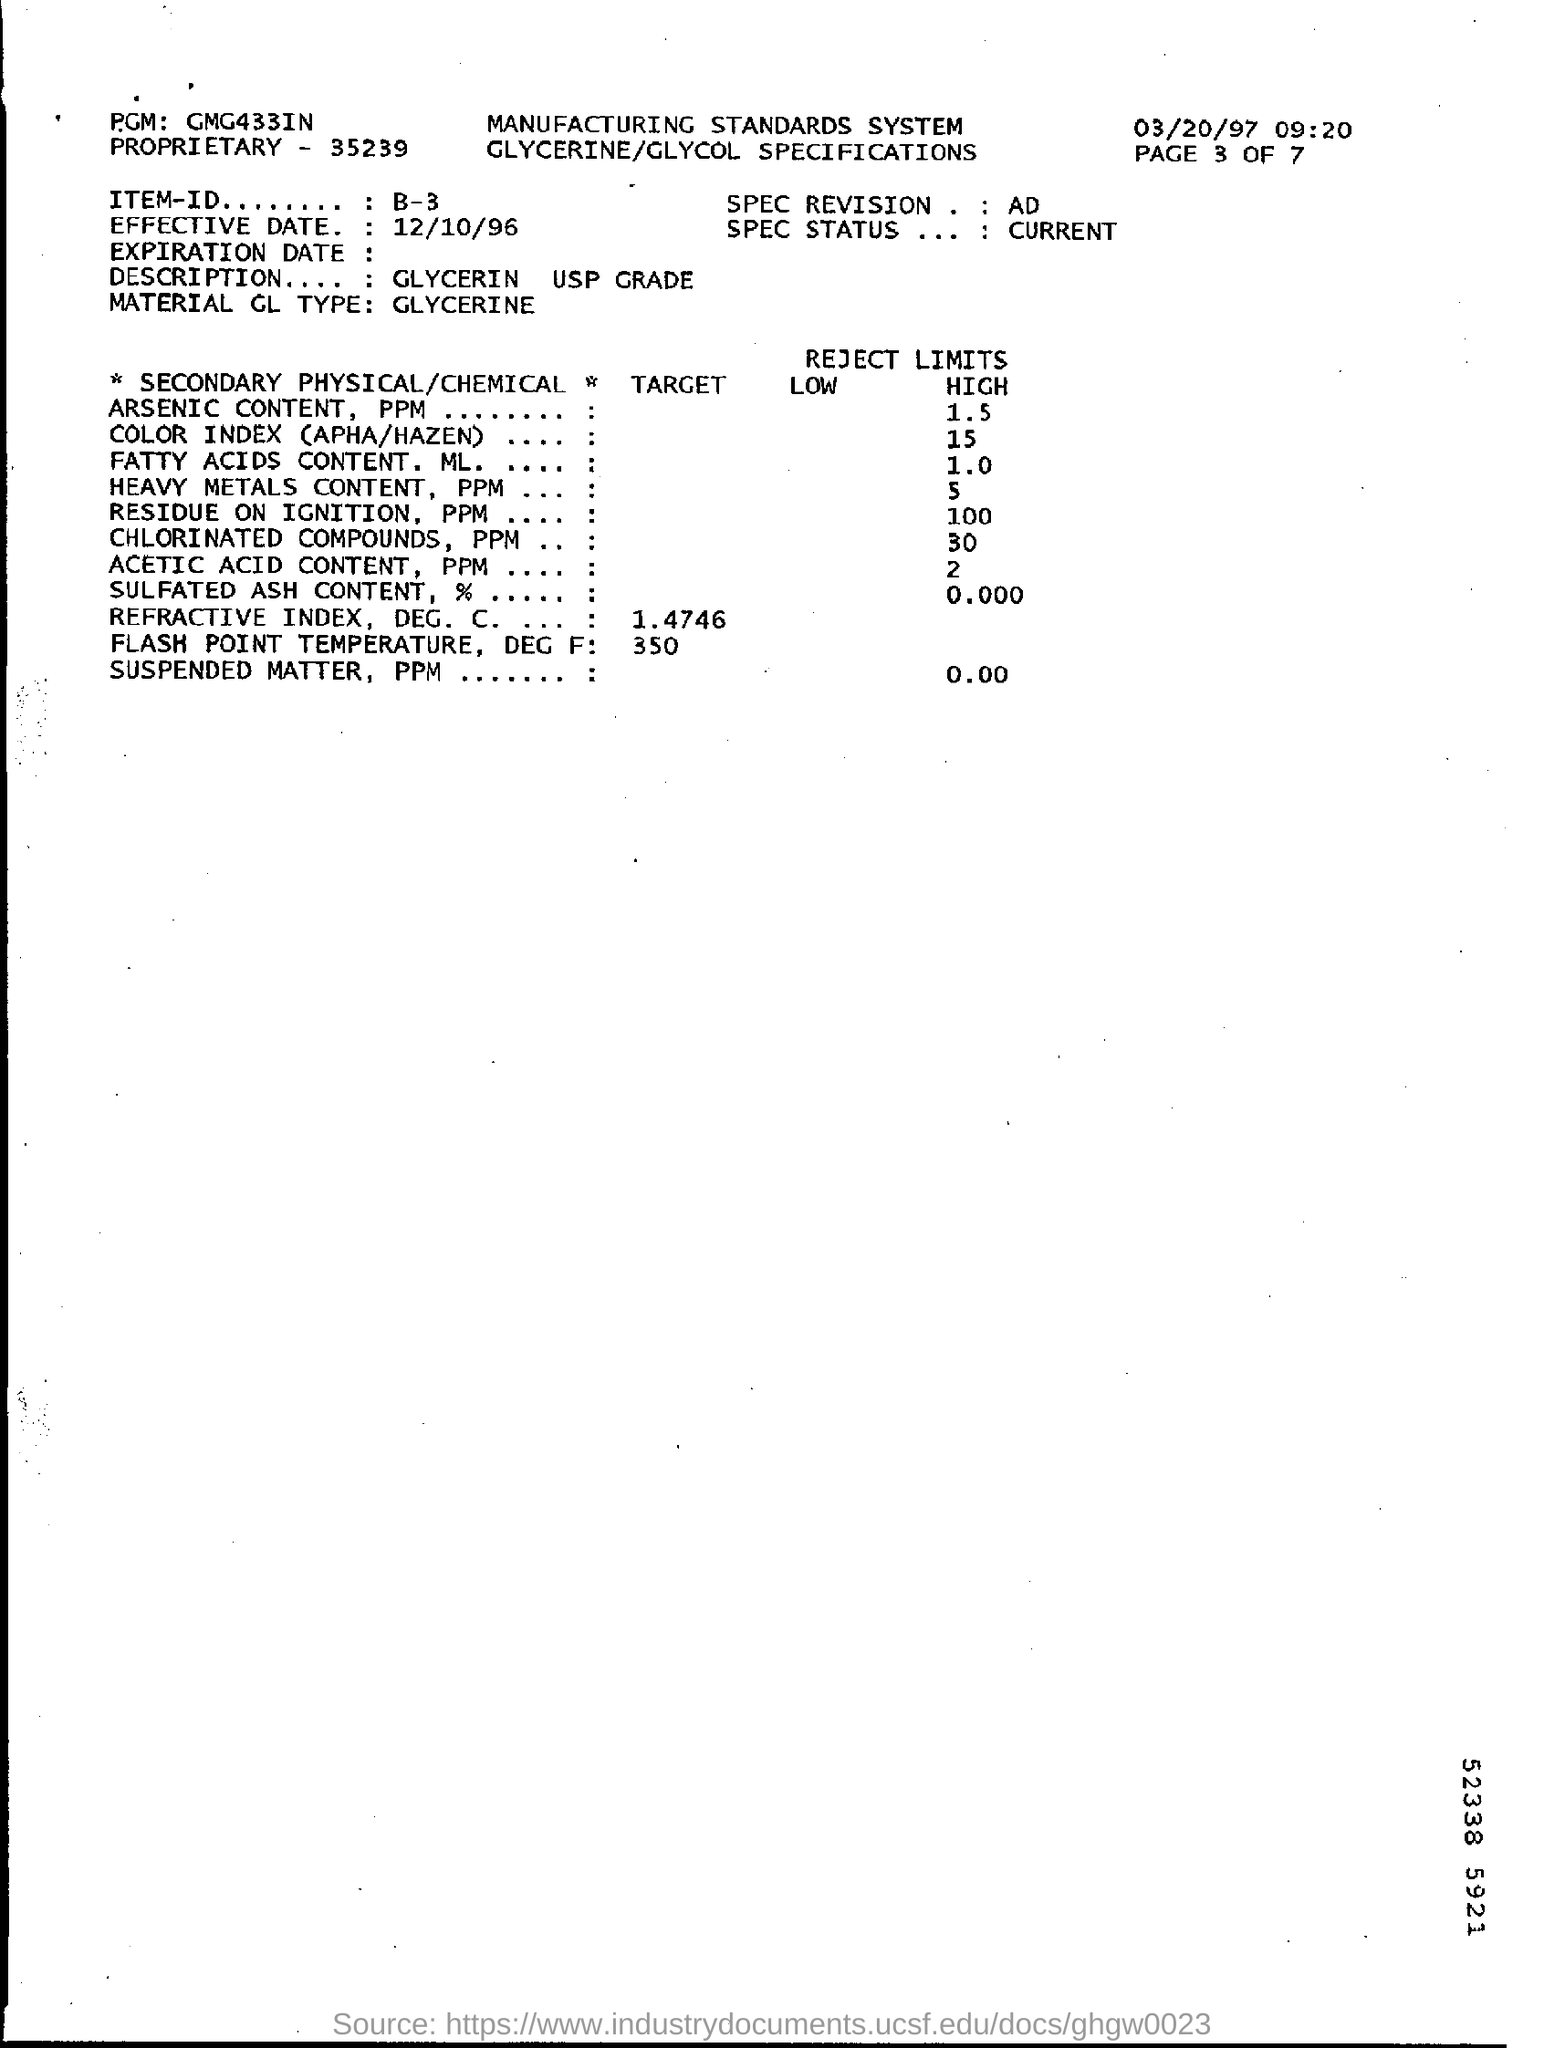Mention a couple of crucial points in this snapshot. Can you please provide the ITEM-ID mentioned as B-3? Glycerin USP Grade is a description that is mentioned. The PGM mentioned is GMG433IN. The effective date of the mentioned information is December 10, 1996. 